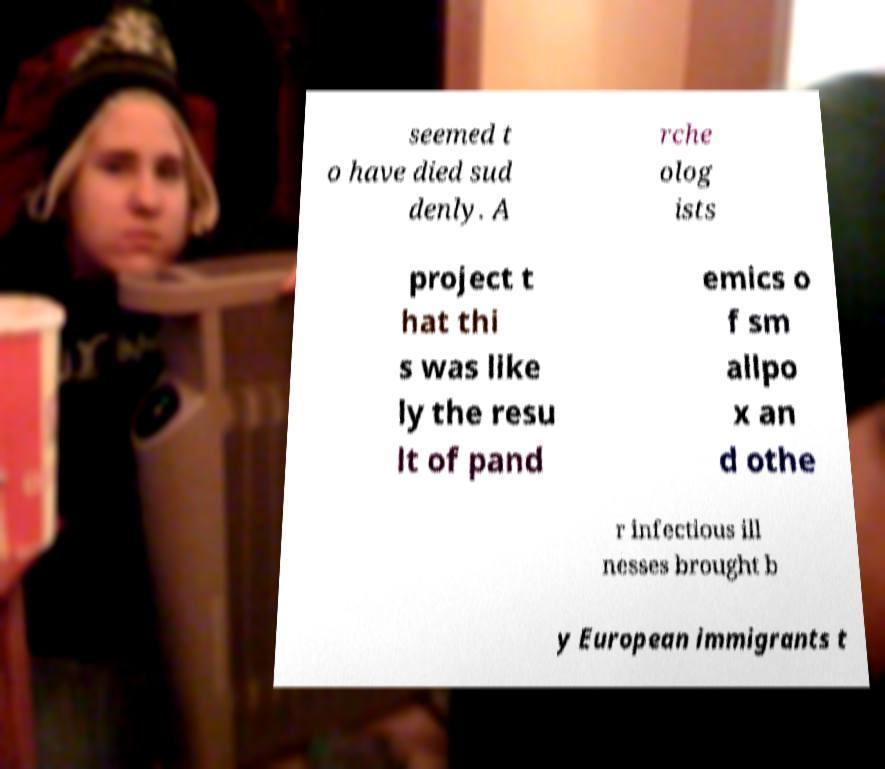There's text embedded in this image that I need extracted. Can you transcribe it verbatim? seemed t o have died sud denly. A rche olog ists project t hat thi s was like ly the resu lt of pand emics o f sm allpo x an d othe r infectious ill nesses brought b y European immigrants t 